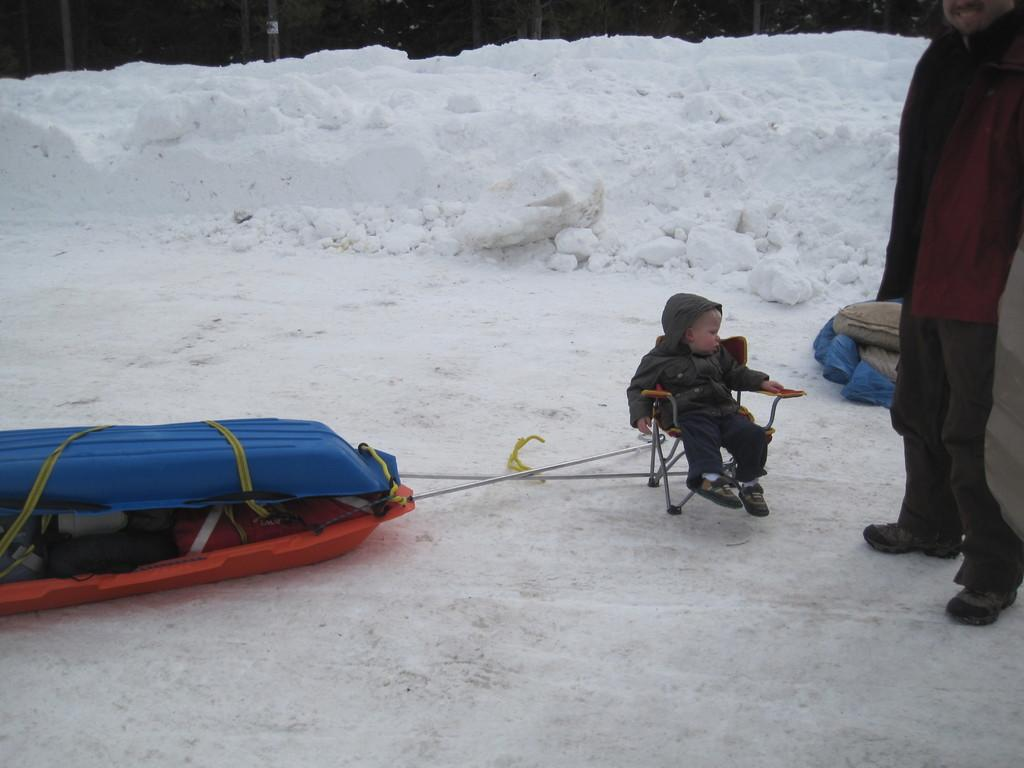Who is the main subject in the image? The main subject in the image is a child. What is the child doing in the image? The child is sitting on a chair in the image. Can you describe the person in the image? There is a person standing on the ground in the image. What can be seen in the background of the image? There are trees in the background of the image. What type of turkey can be seen in the image? There is no turkey present in the image. What color is the sky in the image? The provided facts do not mention the color of the sky in the image. 